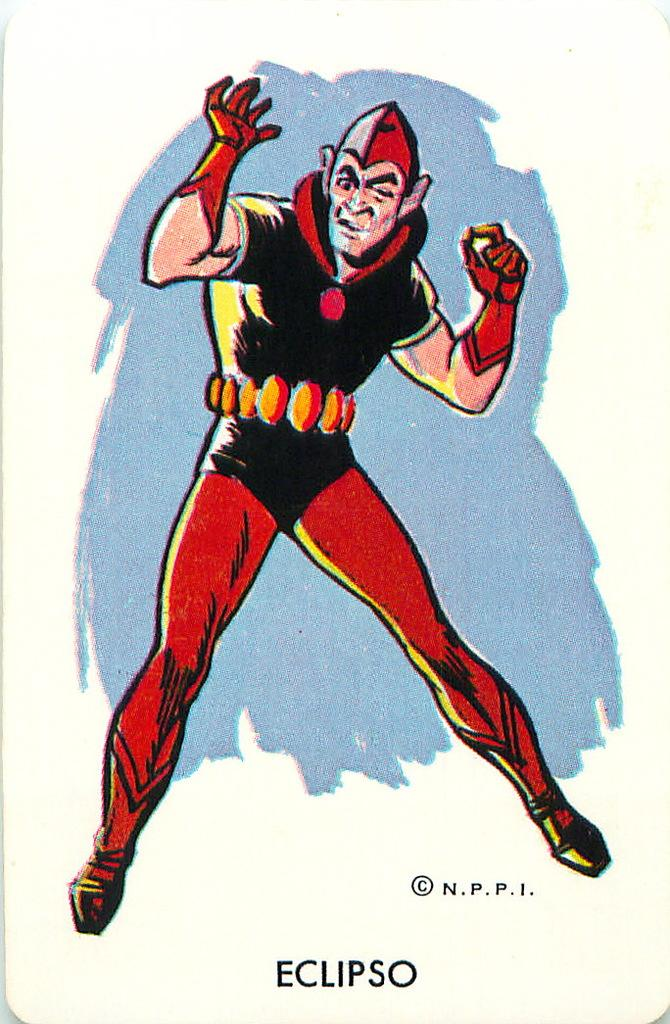What is the main subject of the poster in the image? The poster features a man. Can you describe the man's appearance in the poster? The man is wearing a red cap and a black dress. What is located at the bottom of the poster? There is text at the bottom of the poster. Where is the basin located in the image? There is no basin present in the image. Can you describe the garden featured in the image? There is no garden present in the image; it features a poster with a man. 